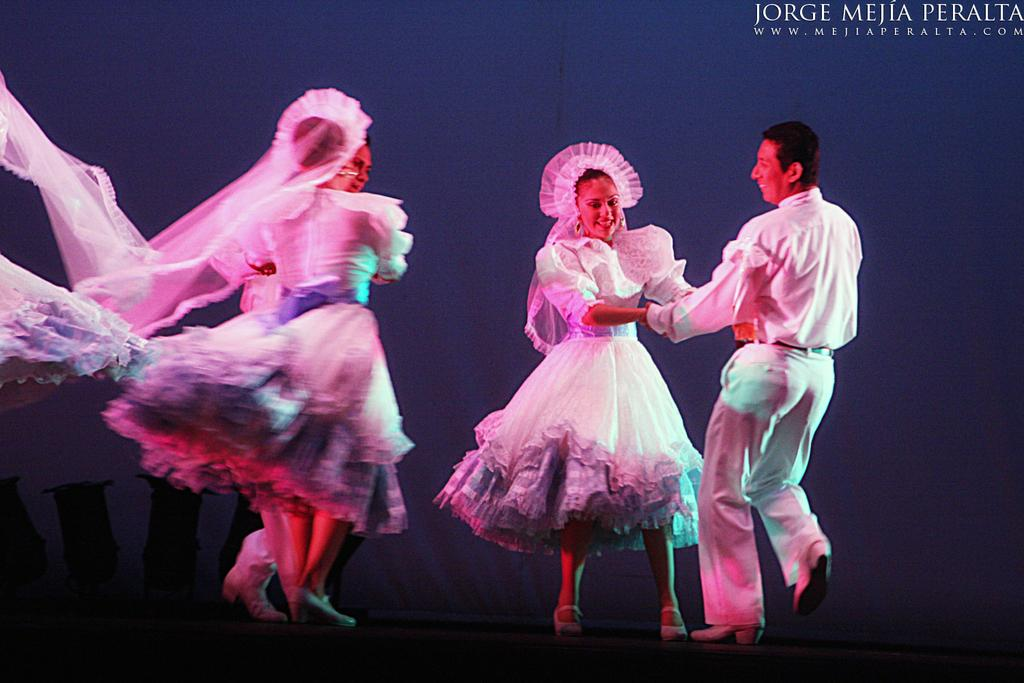How many people are in the image? There are four people in the image, two men and two women. What are the people doing in the image? The people are dancing on the floor. What can be seen in the background of the image? There is a wall in the background of the image. Is there any text visible in the image? Yes, there is text in the top right corner of the image. Can you tell me how many crows are sitting on the van in the image? There is no van or crow present in the image. What type of light bulb is being used by the people in the image? There is no light bulb visible in the image; the people are dancing on the floor. 